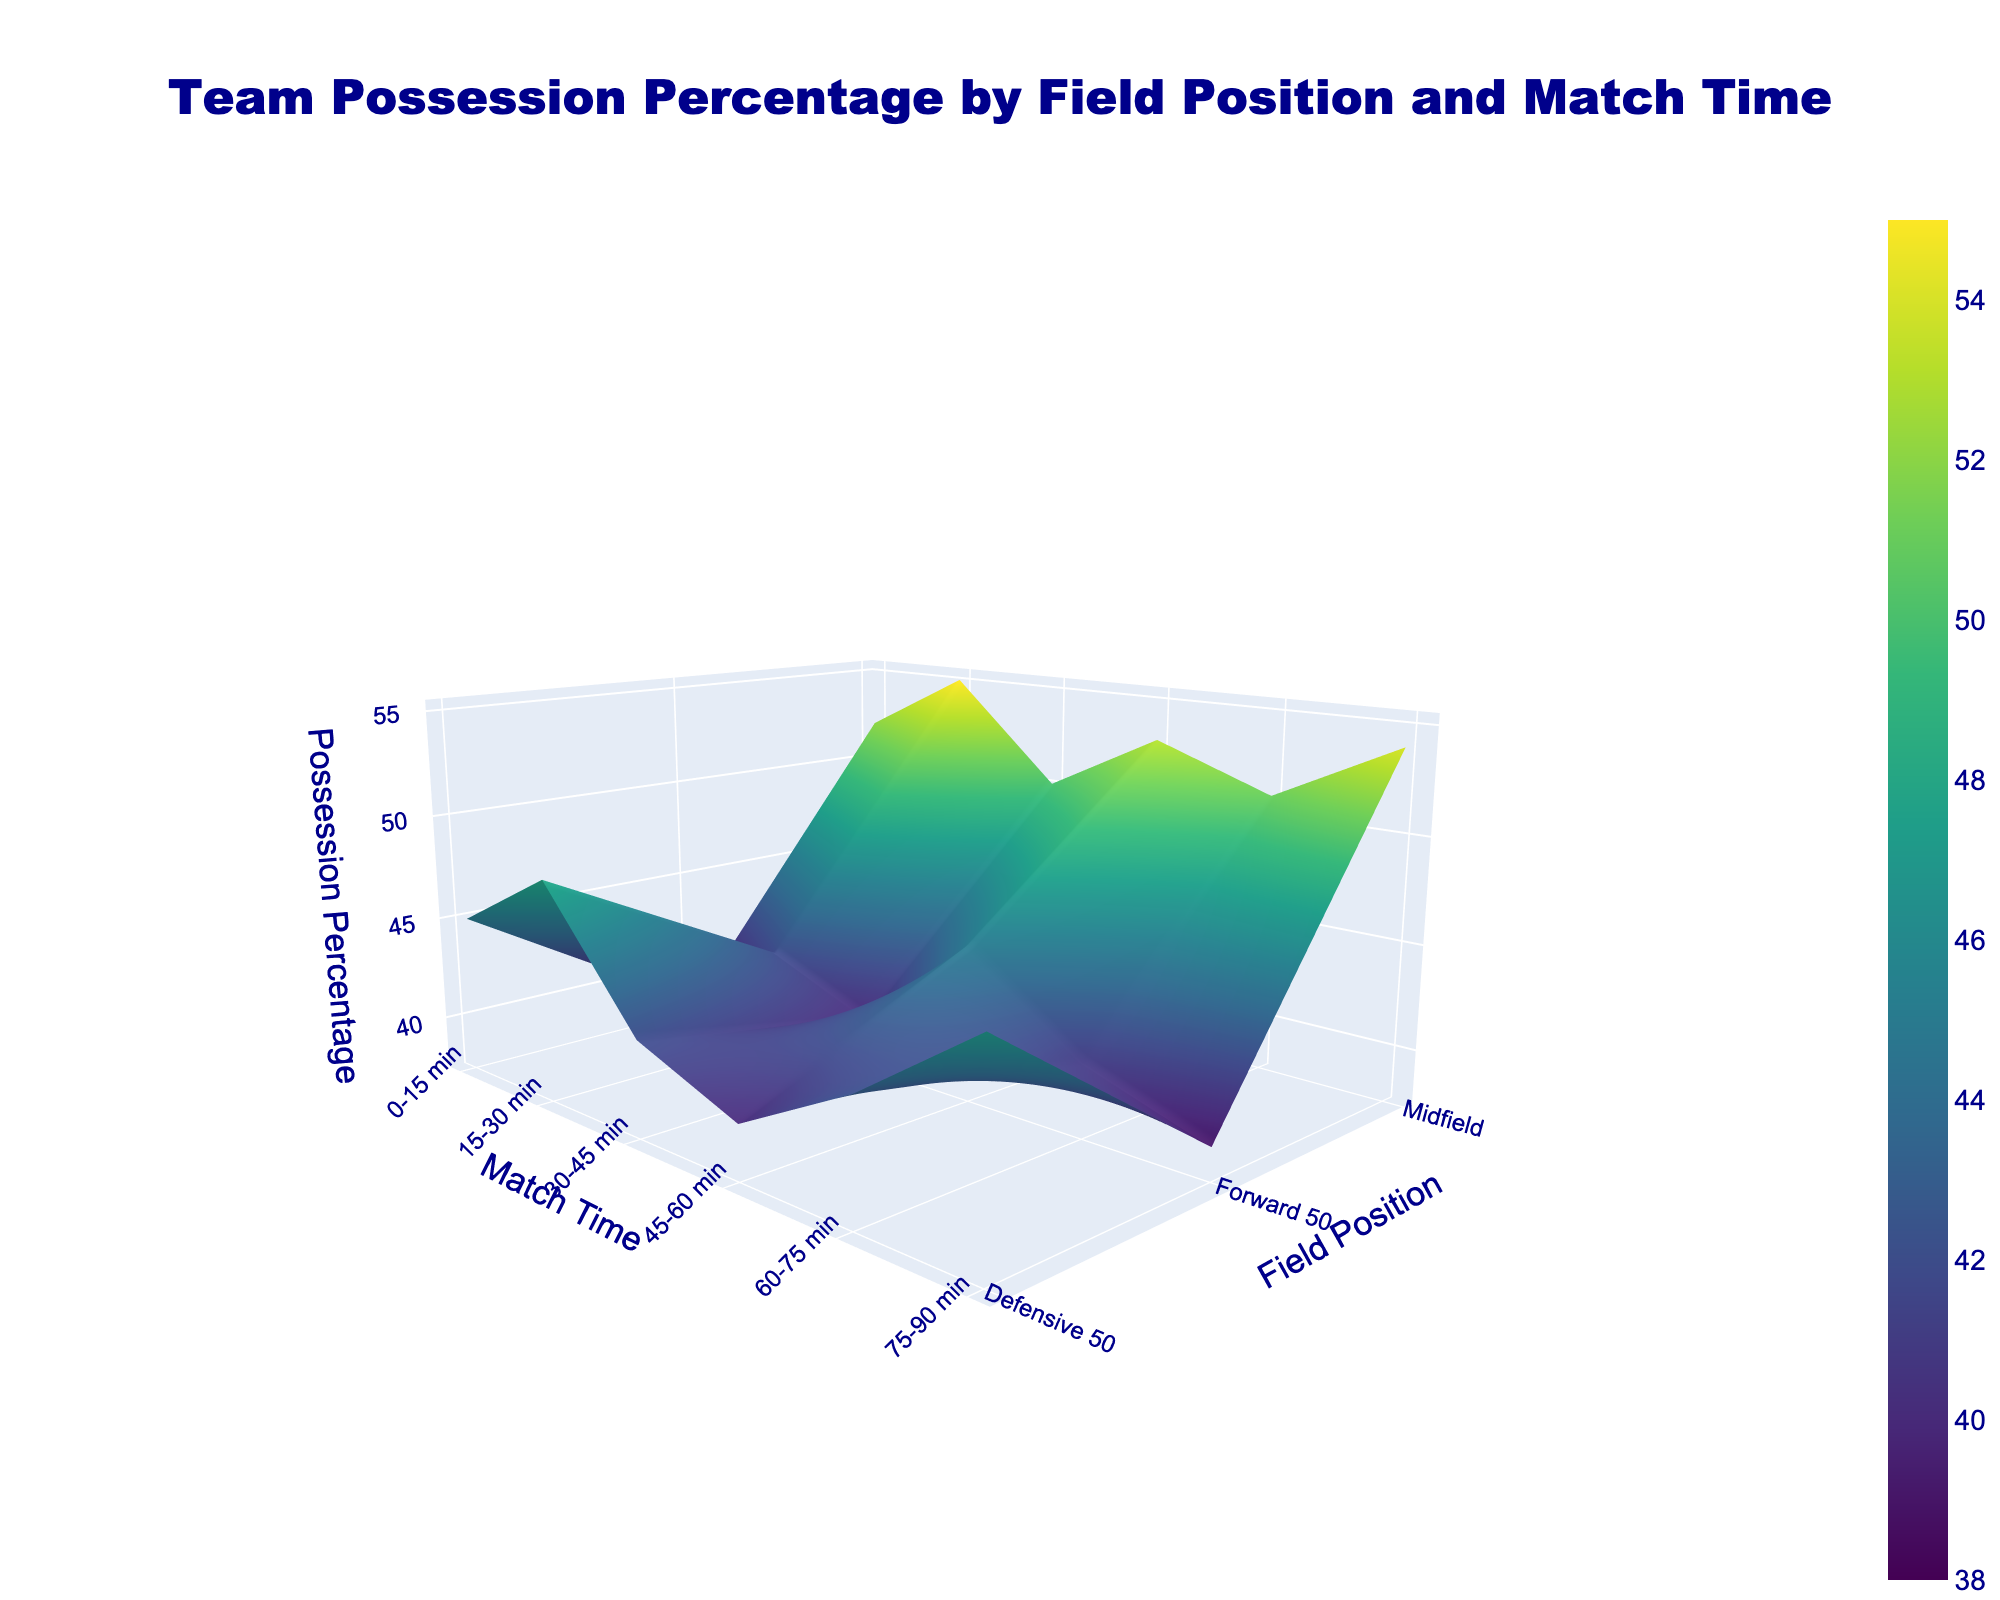What's the title of the 3D surface plot? The title of the 3D surface plot is prominently displayed at the top. It reads: "Team Possession Percentage by Field Position and Match Time"
Answer: Team Possession Percentage by Field Position and Match Time What are the axes titles in the figure? The 3D surface plot has titles for all three axes. The x-axis is titled "Match Time," the y-axis is titled "Field Position," and the z-axis is titled "Possession Percentage."
Answer: Match Time, Field Position, Possession Percentage Which time period in the Forward 50 position has the lowest possession percentage? By looking at the Forward 50 positions across all time periods, the lowest possession percentage comes in the 75-90 min time period, which is indicated to be 39%.
Answer: 75-90 min What is the possession percentage in the Defensive 50 during the 15-30 min period? Looking at the intersection of the Defensive 50 and 15-30 min on the plot, the possession percentage is 48%.
Answer: 48% Which Field Position has the highest possession percentage during the 0-15 min period? By comparing the possession percentages at different Field Positions during the 0-15 min period, it is clear that the Midfield has the highest possession percentage, which is 52%.
Answer: Midfield Is the possession percentage greater in the Forward 50 during 45-60 min or in the Midfield during 60-75 min? By comparing the two values in the specified regions, the Forward 50 during 45-60 min has a possession percentage of 45%, while the Midfield during 60-75 min has a percentage of 51%.
Answer: Midfield during 60-75 min On average, which Field Position has a higher possession percentage over the entire match, Midfield or Defensive 50? To find out, we average the possession percentages for each time period and compare the two. The Midfield has percentages [52, 55, 50, 53, 51, 54], which average to (52+55+50+53+51+54)/6 = 52.5%. The Defensive 50 has percentages [45, 48, 42, 40, 43, 47], averaging to (45+48+42+40+43+47)/6 = 44.17%. Therefore, Midfield has a higher average possession percentage.
Answer: Midfield During which time period does possession in the Defensive 50 decrease the most? By examining the changes between consecutive time periods for Defensive 50: (0-15 to 15-30 min: 3%), (15-30 to 30-45 min: -6%), (30-45 to 45-60 min: -2%), (45-60 to 60-75 min: 3%), (60-75 to 75-90 min: 4%) shows the largest decrease of 6% from 15-30 min to 30-45 min.
Answer: 15-30 min to 30-45 min How does possession in the Forward 50 change from the first quarter to the last quarter of the match? The Forward 50 possession percentage in the 0-15 min period is 38%, and in the 75-90 min period, it is 39%. The change is 39% - 38% = 1% increase.
Answer: 1% increase At what Field Position and time combination does the highest possession percentage occur? By scanning through all the data points on the plot, the highest possession percentage is in the Midfield during the 15-30 min period, which is 55%.
Answer: Midfield, 15-30 min 